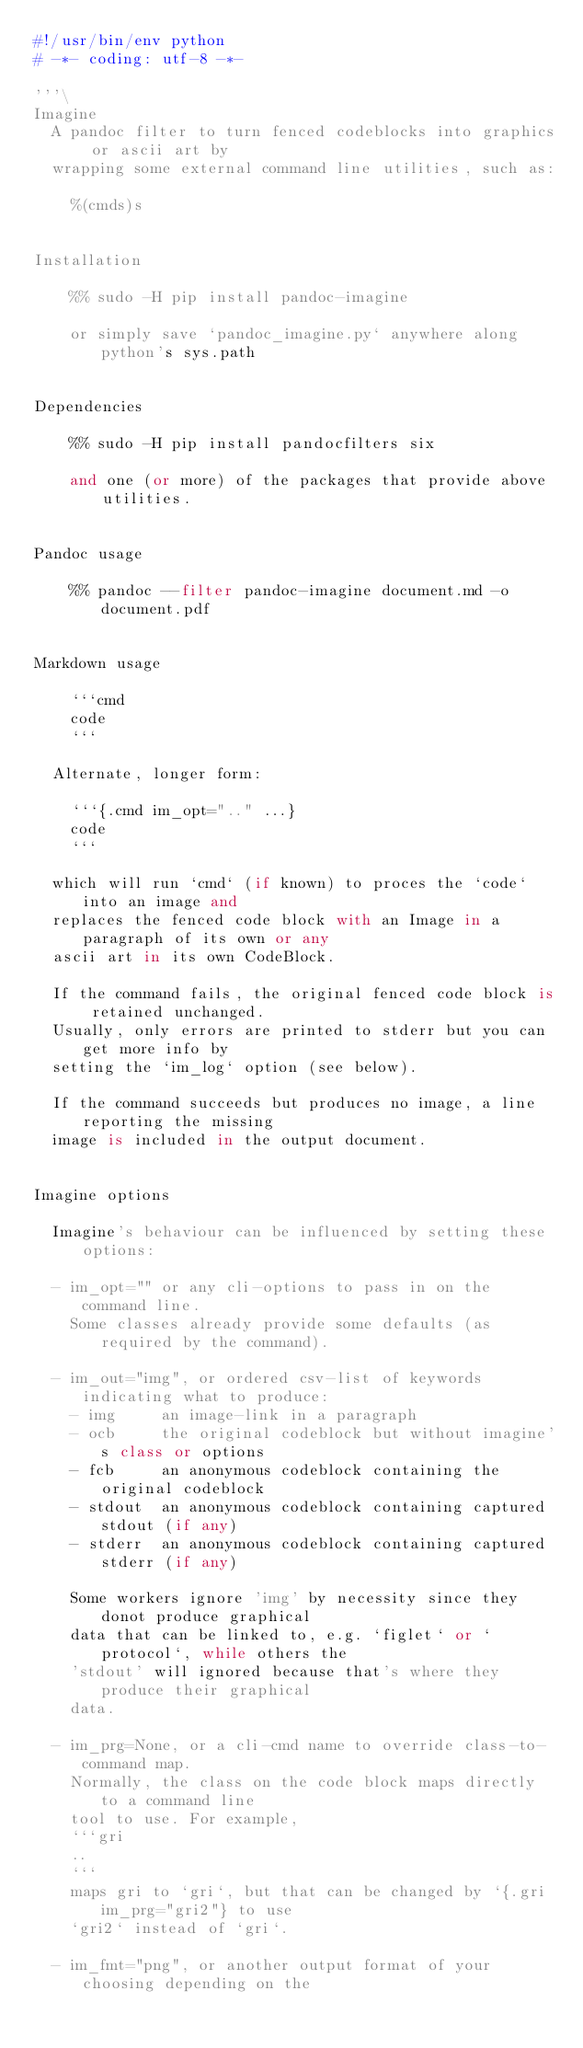Convert code to text. <code><loc_0><loc_0><loc_500><loc_500><_Python_>#!/usr/bin/env python
# -*- coding: utf-8 -*-

'''\
Imagine
  A pandoc filter to turn fenced codeblocks into graphics or ascii art by
  wrapping some external command line utilities, such as:

    %(cmds)s


Installation

    %% sudo -H pip install pandoc-imagine

    or simply save `pandoc_imagine.py` anywhere along python's sys.path


Dependencies

    %% sudo -H pip install pandocfilters six

    and one (or more) of the packages that provide above utilities.


Pandoc usage

    %% pandoc --filter pandoc-imagine document.md -o document.pdf


Markdown usage

    ```cmd
    code
    ```

  Alternate, longer form:

    ```{.cmd im_opt=".." ...}
    code
    ```

  which will run `cmd` (if known) to proces the `code` into an image and
  replaces the fenced code block with an Image in a paragraph of its own or any
  ascii art in its own CodeBlock.

  If the command fails, the original fenced code block is retained unchanged.
  Usually, only errors are printed to stderr but you can get more info by
  setting the `im_log` option (see below).

  If the command succeeds but produces no image, a line reporting the missing
  image is included in the output document.


Imagine options

  Imagine's behaviour can be influenced by setting these options:

  - im_opt="" or any cli-options to pass in on the command line.
    Some classes already provide some defaults (as required by the command).

  - im_out="img", or ordered csv-list of keywords indicating what to produce:
    - img     an image-link in a paragraph
    - ocb     the original codeblock but without imagine's class or options
    - fcb     an anonymous codeblock containing the original codeblock
    - stdout  an anonymous codeblock containing captured stdout (if any)
    - stderr  an anonymous codeblock containing captured stderr (if any)

    Some workers ignore 'img' by necessity since they donot produce graphical
    data that can be linked to, e.g. `figlet` or `protocol`, while others the
    'stdout' will ignored because that's where they produce their graphical
    data.

  - im_prg=None, or a cli-cmd name to override class-to-command map.
    Normally, the class on the code block maps directly to a command line
    tool to use. For example,
    ```gri
    ..
    ```
    maps gri to `gri`, but that can be changed by `{.gri im_prg="gri2"} to use
    `gri2` instead of `gri`.

  - im_fmt="png", or another output format of your choosing depending on the</code> 